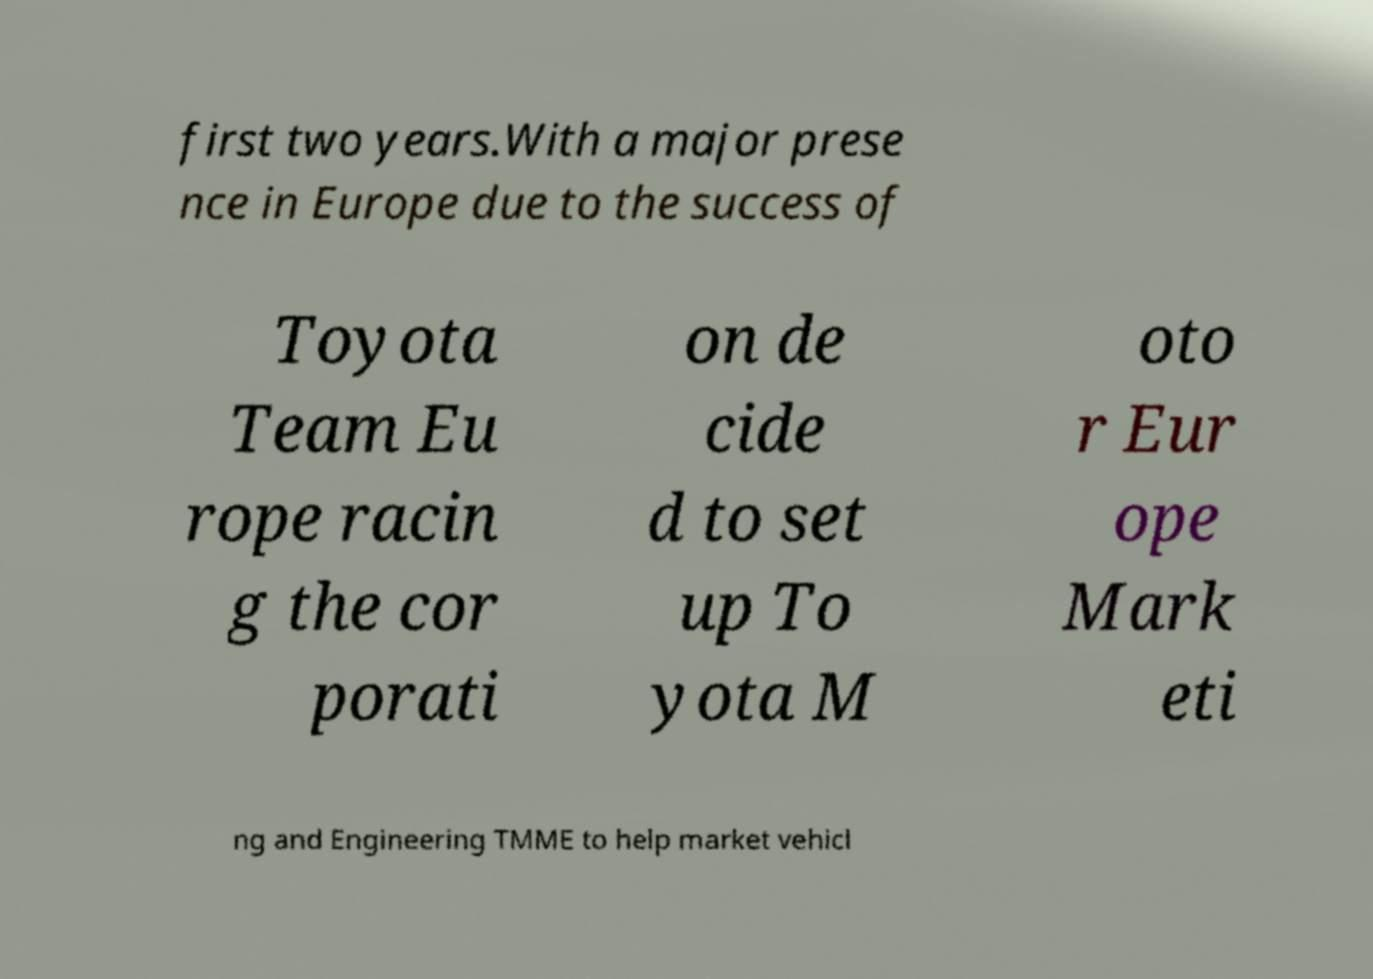Can you accurately transcribe the text from the provided image for me? first two years.With a major prese nce in Europe due to the success of Toyota Team Eu rope racin g the cor porati on de cide d to set up To yota M oto r Eur ope Mark eti ng and Engineering TMME to help market vehicl 